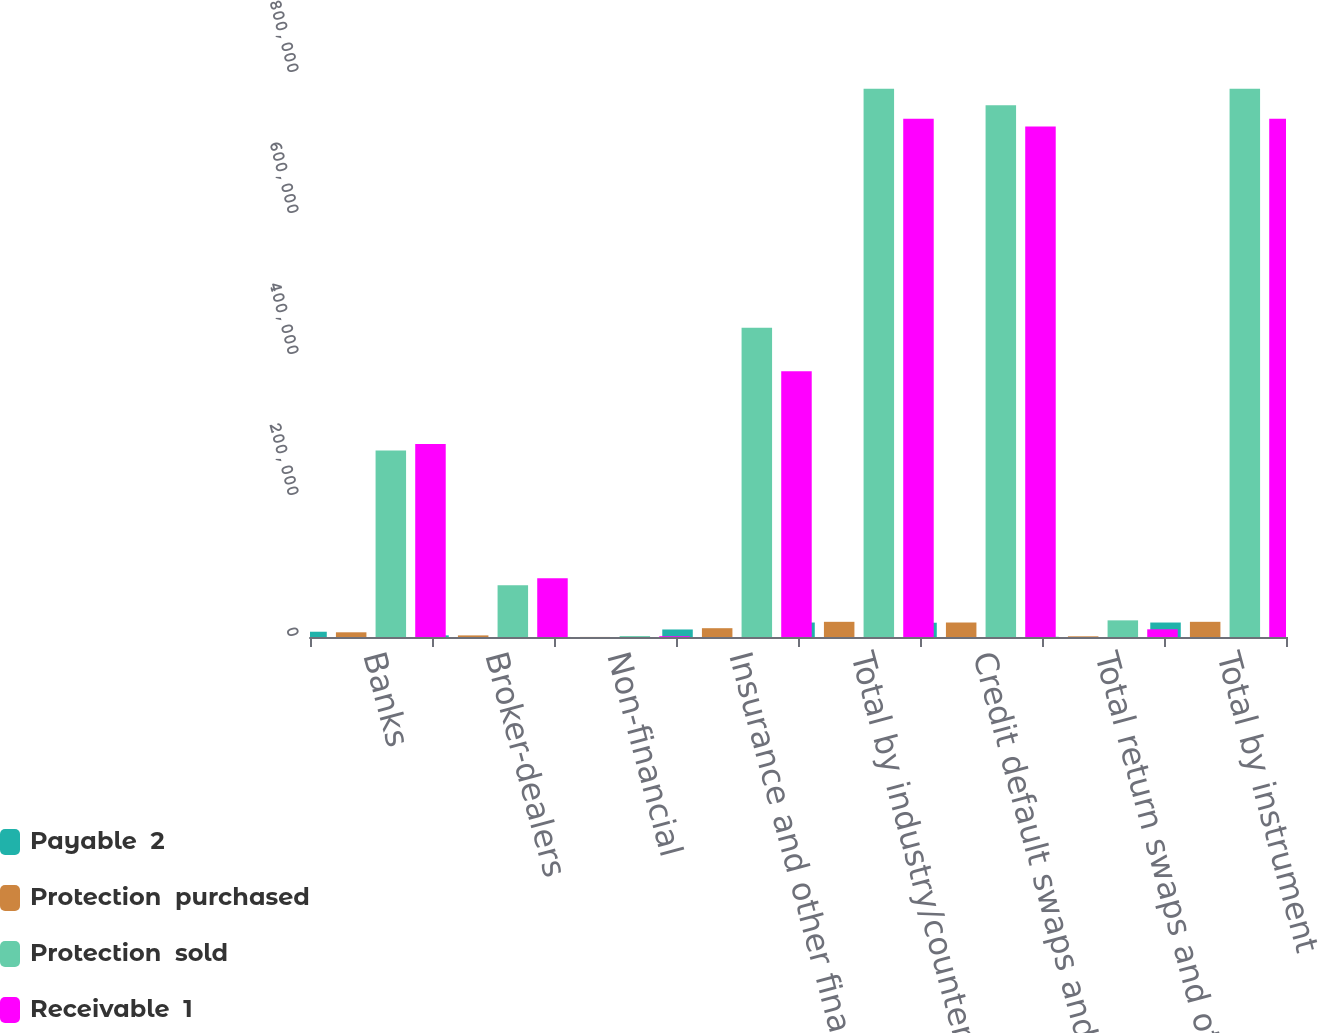Convert chart. <chart><loc_0><loc_0><loc_500><loc_500><stacked_bar_chart><ecel><fcel>Banks<fcel>Broker-dealers<fcel>Non-financial<fcel>Insurance and other financial<fcel>Total by industry/counterparty<fcel>Credit default swaps and<fcel>Total return swaps and other<fcel>Total by instrument<nl><fcel>Payable  2<fcel>7471<fcel>2325<fcel>70<fcel>10668<fcel>20534<fcel>20251<fcel>283<fcel>20534<nl><fcel>Protection  purchased<fcel>6669<fcel>2285<fcel>91<fcel>12488<fcel>21533<fcel>20554<fcel>979<fcel>21533<nl><fcel>Protection  sold<fcel>264414<fcel>73273<fcel>1288<fcel>438738<fcel>777713<fcel>754114<fcel>23599<fcel>777713<nl><fcel>Receivable  1<fcel>273711<fcel>83229<fcel>1140<fcel>377062<fcel>735142<fcel>724228<fcel>10914<fcel>735142<nl></chart> 